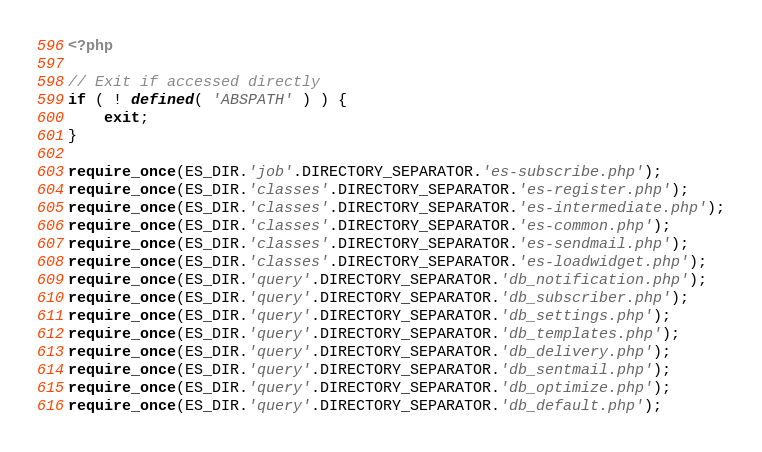<code> <loc_0><loc_0><loc_500><loc_500><_PHP_><?php

// Exit if accessed directly
if ( ! defined( 'ABSPATH' ) ) {
	exit;
}

require_once(ES_DIR.'job'.DIRECTORY_SEPARATOR.'es-subscribe.php');
require_once(ES_DIR.'classes'.DIRECTORY_SEPARATOR.'es-register.php');
require_once(ES_DIR.'classes'.DIRECTORY_SEPARATOR.'es-intermediate.php');
require_once(ES_DIR.'classes'.DIRECTORY_SEPARATOR.'es-common.php');
require_once(ES_DIR.'classes'.DIRECTORY_SEPARATOR.'es-sendmail.php');
require_once(ES_DIR.'classes'.DIRECTORY_SEPARATOR.'es-loadwidget.php');
require_once(ES_DIR.'query'.DIRECTORY_SEPARATOR.'db_notification.php');
require_once(ES_DIR.'query'.DIRECTORY_SEPARATOR.'db_subscriber.php');
require_once(ES_DIR.'query'.DIRECTORY_SEPARATOR.'db_settings.php');
require_once(ES_DIR.'query'.DIRECTORY_SEPARATOR.'db_templates.php');
require_once(ES_DIR.'query'.DIRECTORY_SEPARATOR.'db_delivery.php');
require_once(ES_DIR.'query'.DIRECTORY_SEPARATOR.'db_sentmail.php');
require_once(ES_DIR.'query'.DIRECTORY_SEPARATOR.'db_optimize.php');
require_once(ES_DIR.'query'.DIRECTORY_SEPARATOR.'db_default.php');</code> 